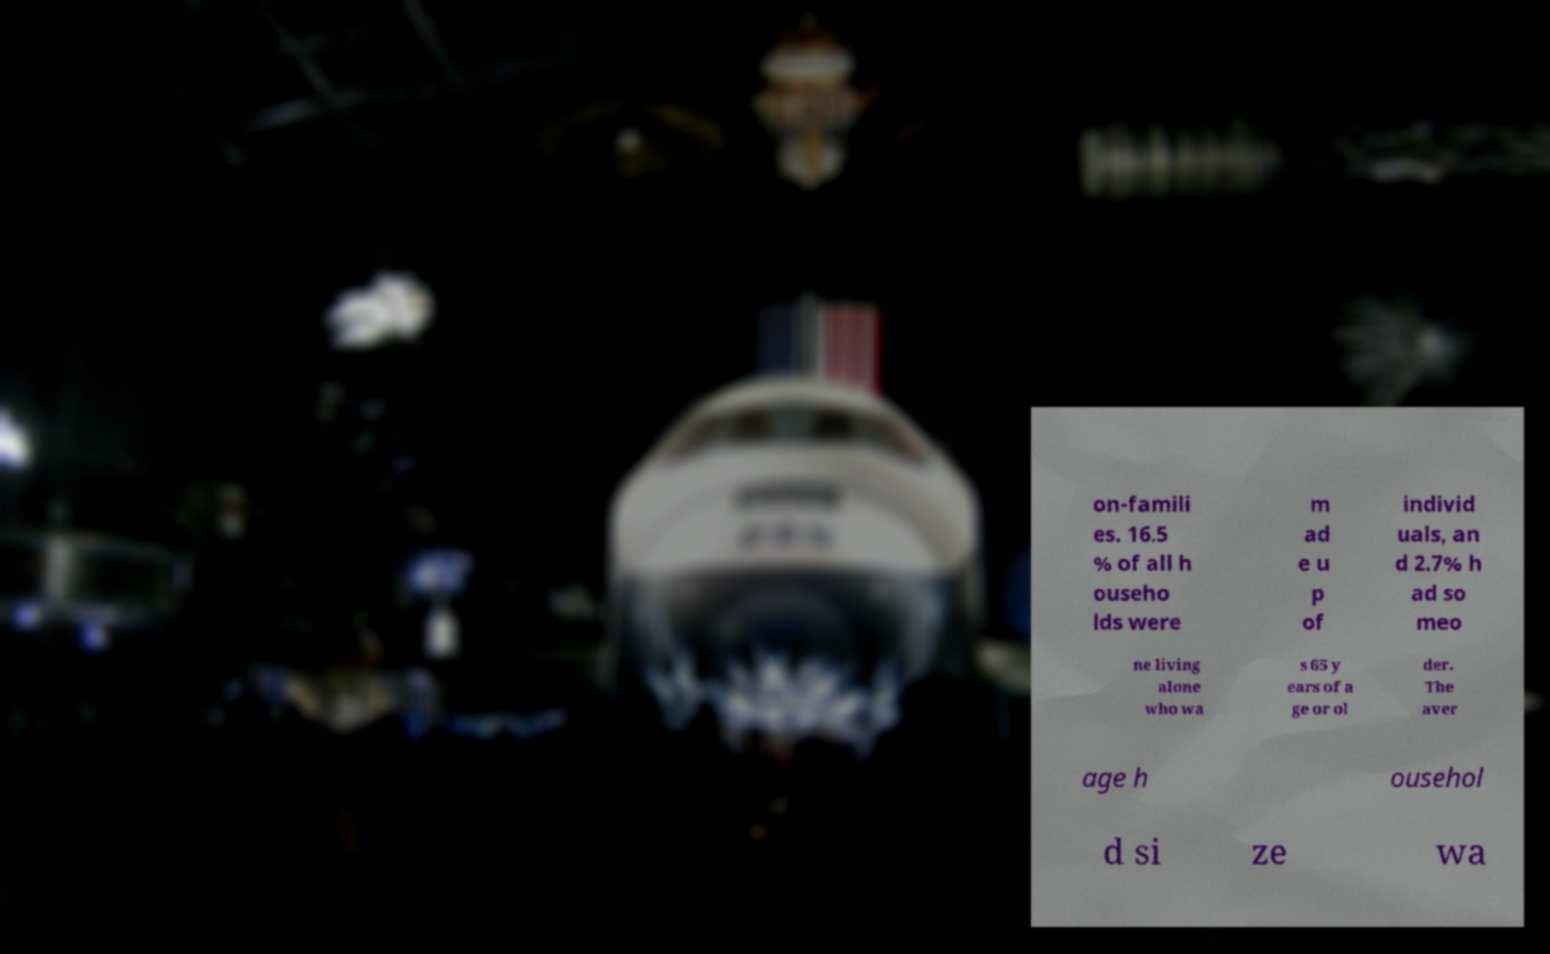There's text embedded in this image that I need extracted. Can you transcribe it verbatim? on-famili es. 16.5 % of all h ouseho lds were m ad e u p of individ uals, an d 2.7% h ad so meo ne living alone who wa s 65 y ears of a ge or ol der. The aver age h ousehol d si ze wa 